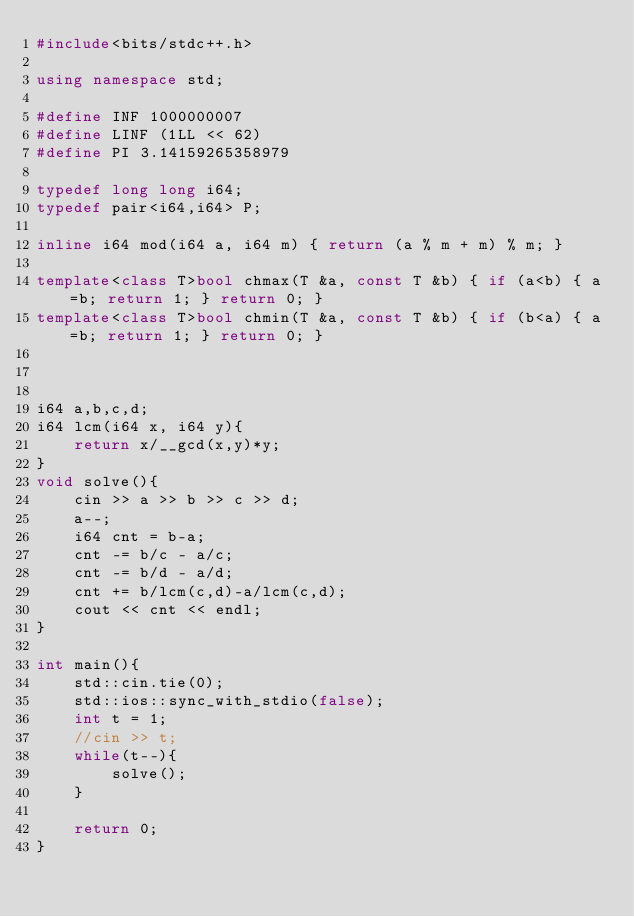Convert code to text. <code><loc_0><loc_0><loc_500><loc_500><_C++_>#include<bits/stdc++.h>

using namespace std;

#define INF 1000000007
#define LINF (1LL << 62)
#define PI 3.14159265358979

typedef long long i64;
typedef pair<i64,i64> P;

inline i64 mod(i64 a, i64 m) { return (a % m + m) % m; }

template<class T>bool chmax(T &a, const T &b) { if (a<b) { a=b; return 1; } return 0; }
template<class T>bool chmin(T &a, const T &b) { if (b<a) { a=b; return 1; } return 0; }



i64 a,b,c,d;
i64 lcm(i64 x, i64 y){
	return x/__gcd(x,y)*y;
}
void solve(){
	cin >> a >> b >> c >> d;
	a--;
	i64 cnt = b-a;
	cnt -= b/c - a/c;
	cnt -= b/d - a/d;
	cnt += b/lcm(c,d)-a/lcm(c,d);
	cout << cnt << endl;
}

int main(){
	std::cin.tie(0);
	std::ios::sync_with_stdio(false);
	int t = 1;
	//cin >> t;
	while(t--){
		solve();
	}
	
	return 0;
}</code> 